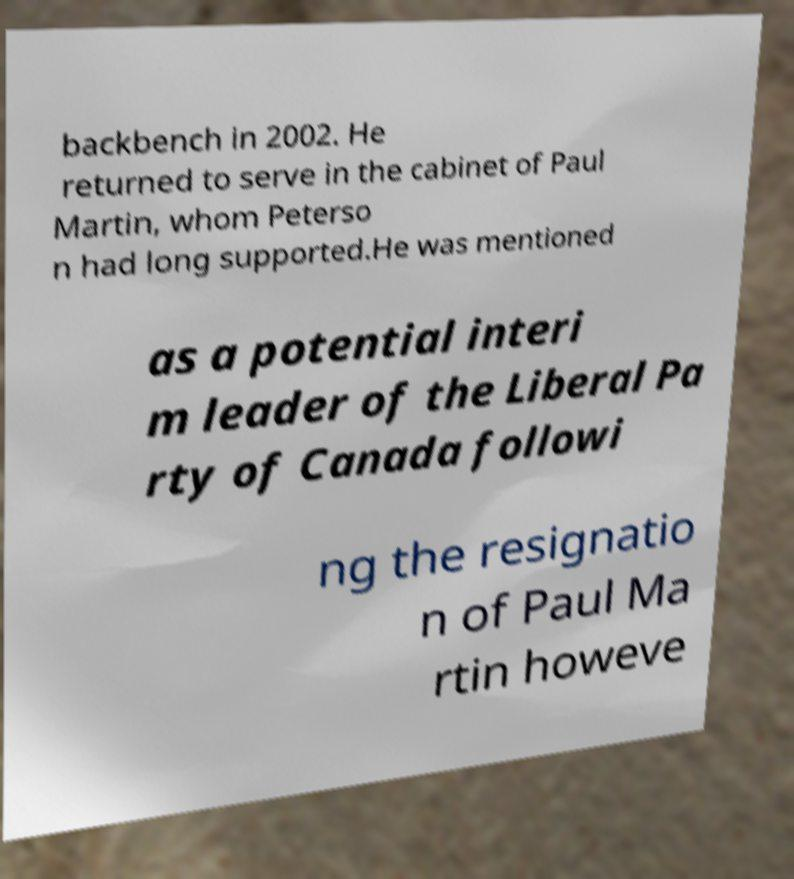For documentation purposes, I need the text within this image transcribed. Could you provide that? backbench in 2002. He returned to serve in the cabinet of Paul Martin, whom Peterso n had long supported.He was mentioned as a potential interi m leader of the Liberal Pa rty of Canada followi ng the resignatio n of Paul Ma rtin howeve 